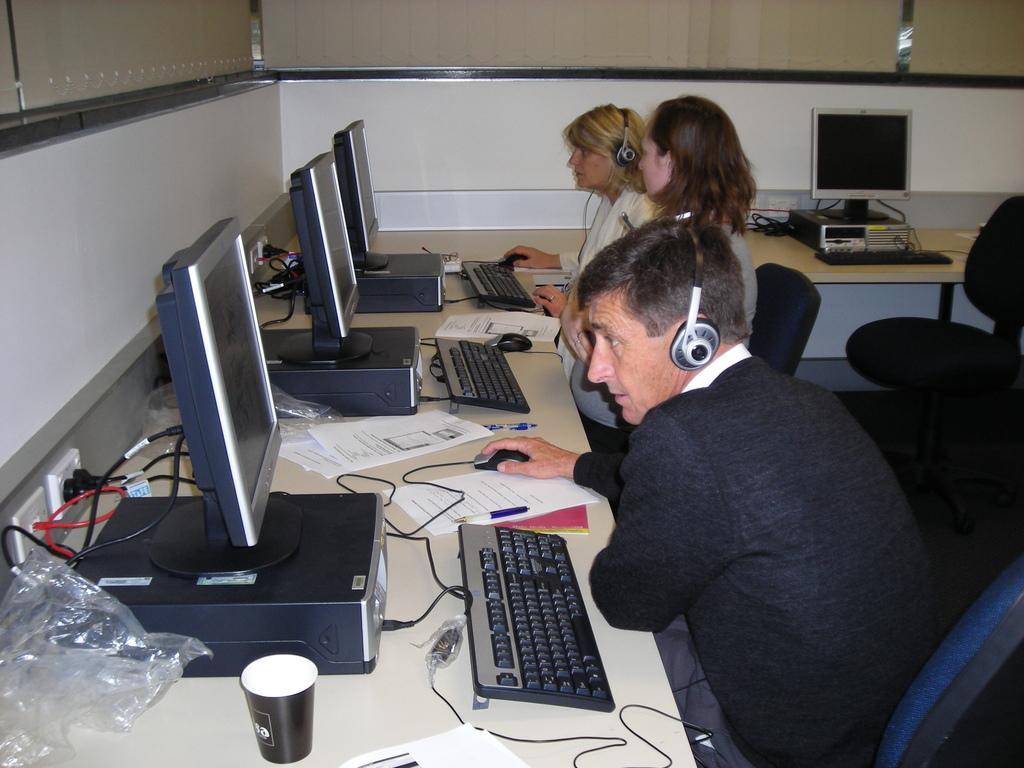How would you summarize this image in a sentence or two? In this picture we can see persons sitting on chairs in front of a table , wearing headsets and on the table we can see cpu, monitor, keyboard, mouse, glass, cover, papers, pen. 